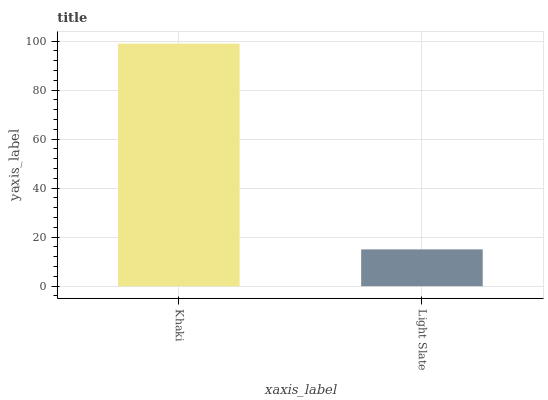Is Light Slate the minimum?
Answer yes or no. Yes. Is Khaki the maximum?
Answer yes or no. Yes. Is Light Slate the maximum?
Answer yes or no. No. Is Khaki greater than Light Slate?
Answer yes or no. Yes. Is Light Slate less than Khaki?
Answer yes or no. Yes. Is Light Slate greater than Khaki?
Answer yes or no. No. Is Khaki less than Light Slate?
Answer yes or no. No. Is Khaki the high median?
Answer yes or no. Yes. Is Light Slate the low median?
Answer yes or no. Yes. Is Light Slate the high median?
Answer yes or no. No. Is Khaki the low median?
Answer yes or no. No. 